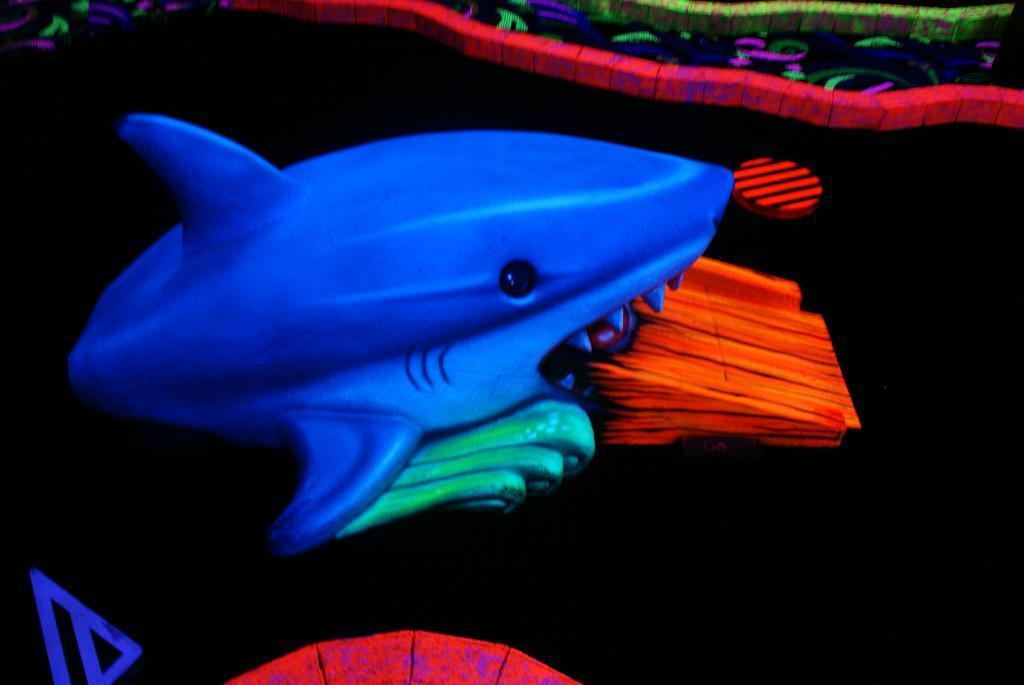Can you describe this image briefly? Here I can see a toy fish which is in blue color. The background is in black color. It is looking like an edited image. 